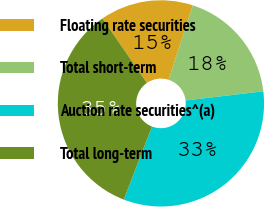<chart> <loc_0><loc_0><loc_500><loc_500><pie_chart><fcel>Floating rate securities<fcel>Total short-term<fcel>Auction rate securities^(a)<fcel>Total long-term<nl><fcel>14.61%<fcel>18.12%<fcel>32.73%<fcel>34.54%<nl></chart> 